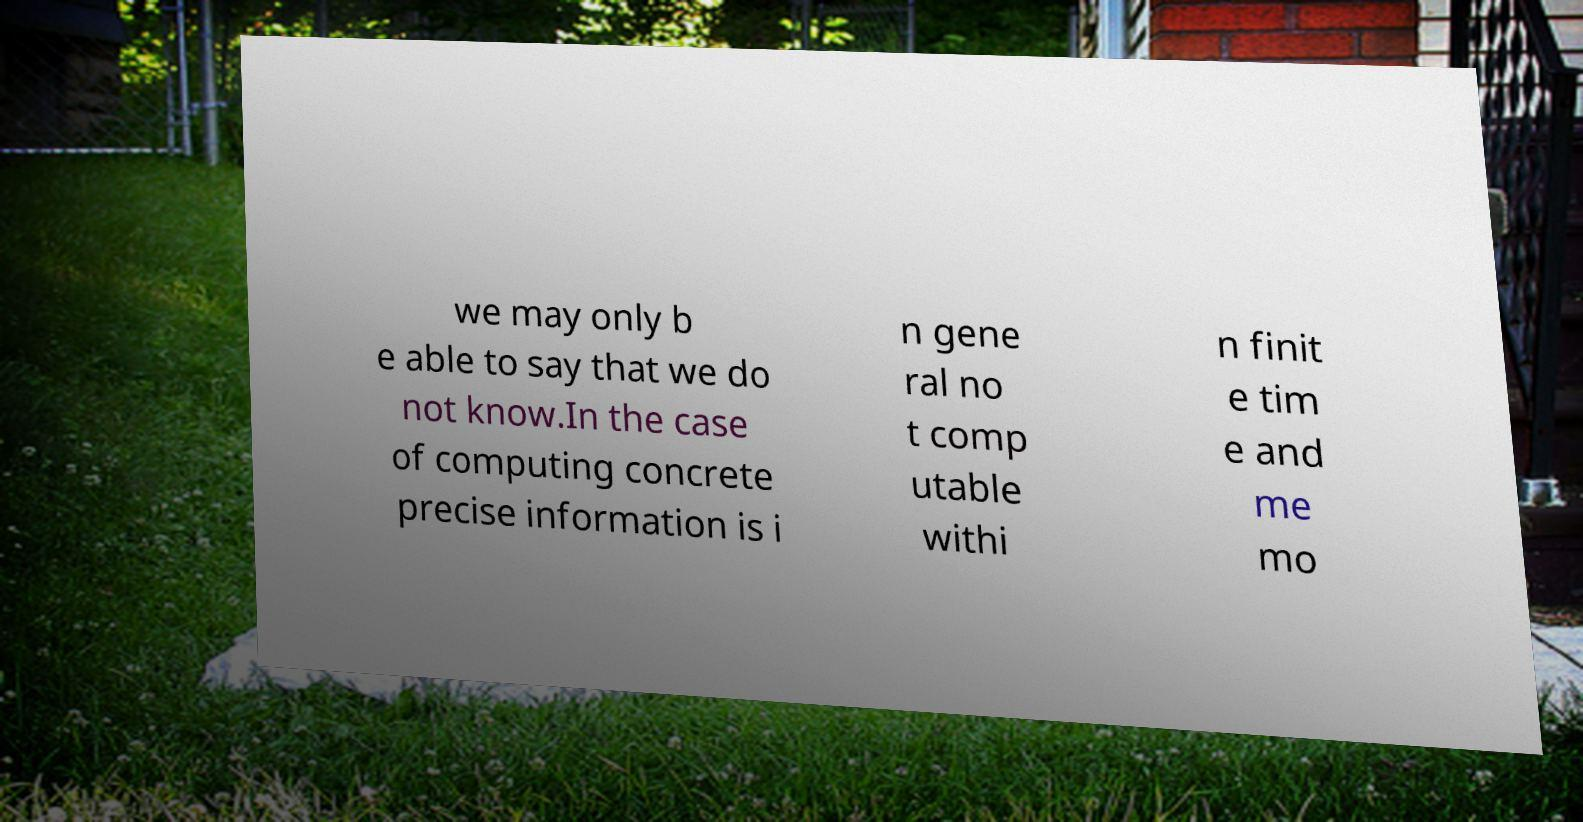Can you read and provide the text displayed in the image?This photo seems to have some interesting text. Can you extract and type it out for me? we may only b e able to say that we do not know.In the case of computing concrete precise information is i n gene ral no t comp utable withi n finit e tim e and me mo 